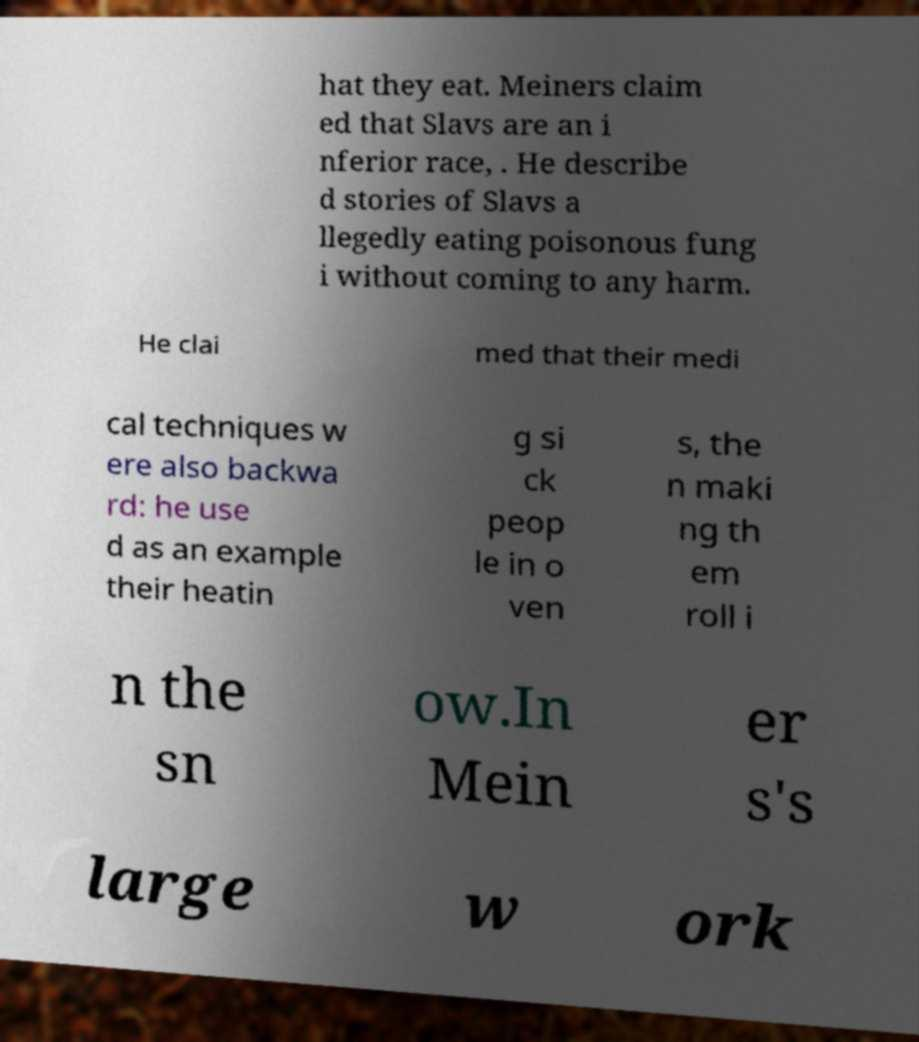Could you assist in decoding the text presented in this image and type it out clearly? hat they eat. Meiners claim ed that Slavs are an i nferior race, . He describe d stories of Slavs a llegedly eating poisonous fung i without coming to any harm. He clai med that their medi cal techniques w ere also backwa rd: he use d as an example their heatin g si ck peop le in o ven s, the n maki ng th em roll i n the sn ow.In Mein er s's large w ork 